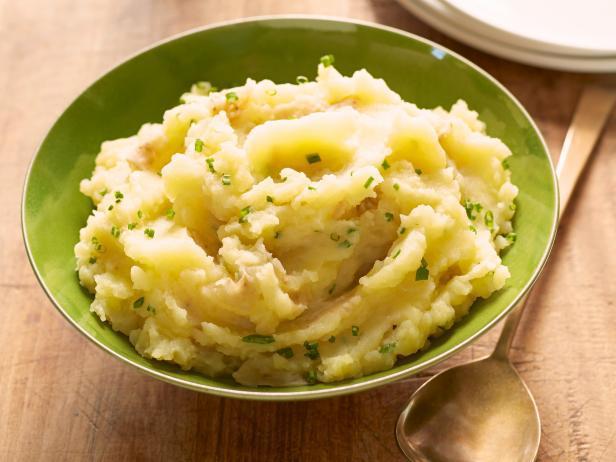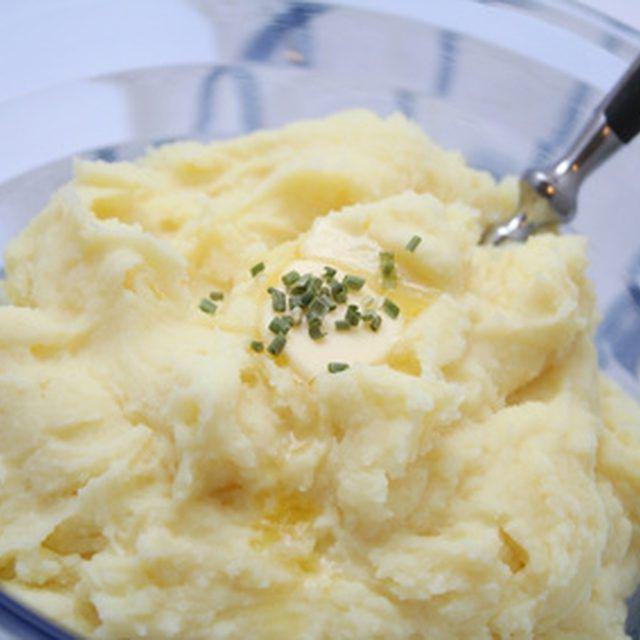The first image is the image on the left, the second image is the image on the right. Examine the images to the left and right. Is the description "The mashed potatoes on the right have a spoon handle visibly sticking out of them" accurate? Answer yes or no. Yes. 